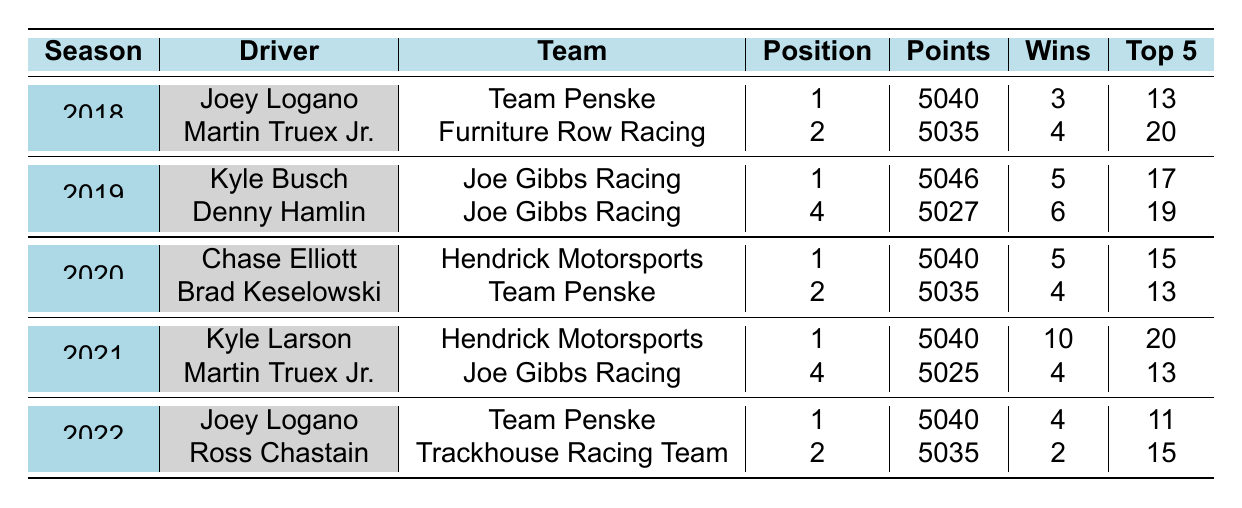What was the finishing position of Kyle Larson in 2021? In the row for the 2021 season, under the driver Kyle Larson, the finishing position listed is 1.
Answer: 1 Which driver had the most wins in the 2021 season? The row for Kyle Larson in 2021 indicates he had 10 wins, which is higher than any other driver in that season's data provided.
Answer: Kyle Larson Did Martin Truex Jr. finish in the top 3 in any season provided? In the table, Martin Truex Jr. finished 2nd in 2018 and 4th in both 2019 and 2021; therefore, he finished in the top 3 in 2018.
Answer: Yes What is the average points earned by drivers who finished in 1st place over the seasons? The first-place finishers are Joey Logano in 2018 with 5040 points, Kyle Busch in 2019 with 5046 points, Chase Elliott in 2020 with 5040 points, Kyle Larson in 2021 with 5040 points, and Joey Logano again in 2022 with 5040 points. The sum is 5040 + 5046 + 5040 + 5040 + 5040 = 25206. There are 5 entries, so the average is 25206 / 5 = 5041.2.
Answer: 5041.2 Which team had the driver with the highest points in 2019? In 2019, Kyle Busch from Joe Gibbs Racing had the highest points of 5046, compared to Denny Hamlin's 5027 in the same season.
Answer: Joe Gibbs Racing How many total top 5 finishes did the drivers achieve in 2022? Joey Logano had 11 top 5 finishes and Ross Chastain had 15 in 2022. Adding these together gives 11 + 15 = 26 total top 5 finishes for that year.
Answer: 26 Was there any driver who finished 2nd in more than one season? Joey Logano finished 2nd in 2018, and Ross Chastain finished 2nd in 2022, but none finished 2nd in more than one listed season, so the answer is based on provided data.
Answer: No What is the total points earned by all drivers over the seasons? Summing all points: 5040 + 5035 + 5046 + 5027 + 5040 + 5035 + 5040 + 5025 + 5040 + 5035 = 50266.
Answer: 50266 